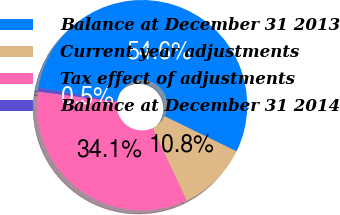Convert chart to OTSL. <chart><loc_0><loc_0><loc_500><loc_500><pie_chart><fcel>Balance at December 31 2013<fcel>Current year adjustments<fcel>Tax effect of adjustments<fcel>Balance at December 31 2014<nl><fcel>54.59%<fcel>10.81%<fcel>34.05%<fcel>0.54%<nl></chart> 